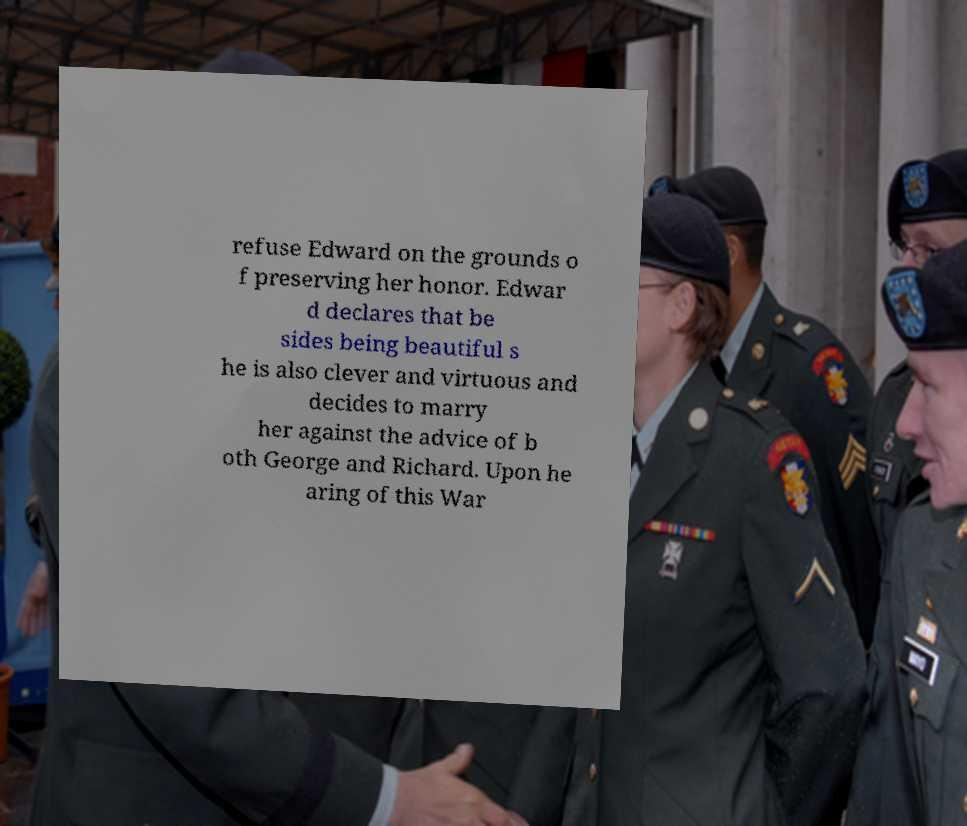What messages or text are displayed in this image? I need them in a readable, typed format. refuse Edward on the grounds o f preserving her honor. Edwar d declares that be sides being beautiful s he is also clever and virtuous and decides to marry her against the advice of b oth George and Richard. Upon he aring of this War 